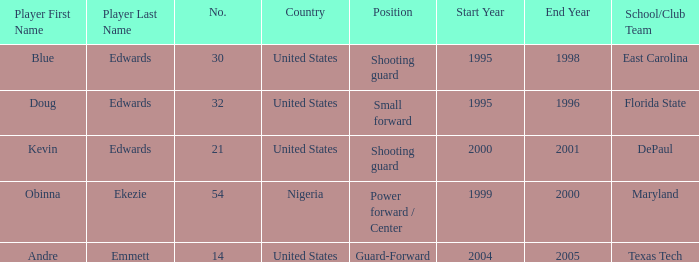What's the highest player number from the list from 2000-2001 21.0. 